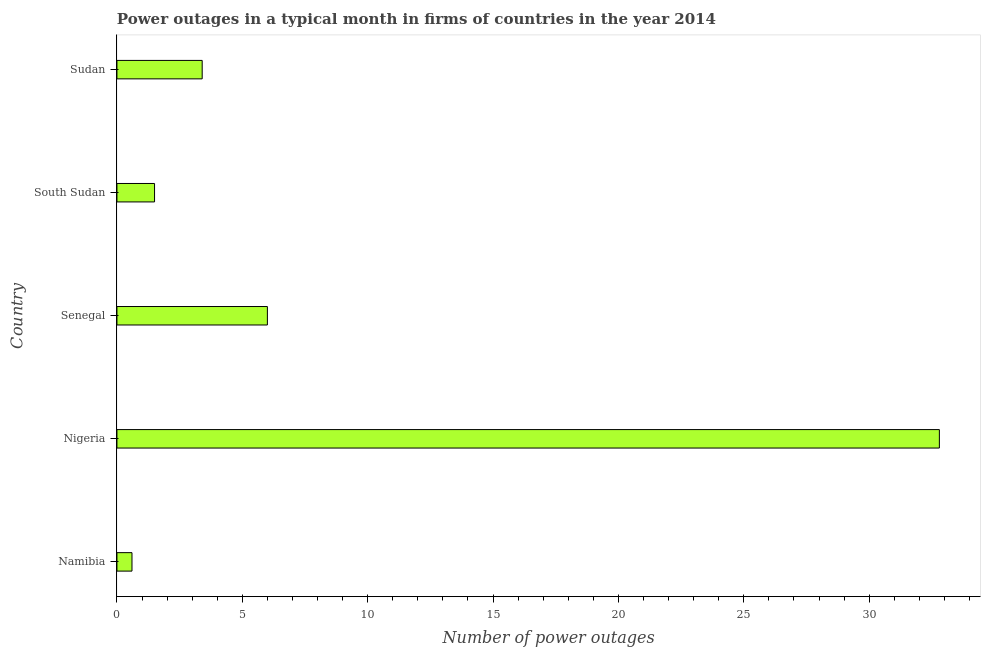What is the title of the graph?
Provide a succinct answer. Power outages in a typical month in firms of countries in the year 2014. What is the label or title of the X-axis?
Offer a terse response. Number of power outages. What is the label or title of the Y-axis?
Provide a short and direct response. Country. What is the number of power outages in South Sudan?
Give a very brief answer. 1.5. Across all countries, what is the maximum number of power outages?
Give a very brief answer. 32.8. In which country was the number of power outages maximum?
Your response must be concise. Nigeria. In which country was the number of power outages minimum?
Ensure brevity in your answer.  Namibia. What is the sum of the number of power outages?
Your answer should be very brief. 44.3. What is the difference between the number of power outages in Namibia and Senegal?
Your answer should be compact. -5.4. What is the average number of power outages per country?
Offer a very short reply. 8.86. In how many countries, is the number of power outages greater than 7 ?
Offer a terse response. 1. What is the ratio of the number of power outages in Namibia to that in Sudan?
Give a very brief answer. 0.18. Is the difference between the number of power outages in Namibia and Senegal greater than the difference between any two countries?
Give a very brief answer. No. What is the difference between the highest and the second highest number of power outages?
Make the answer very short. 26.8. What is the difference between the highest and the lowest number of power outages?
Provide a short and direct response. 32.2. In how many countries, is the number of power outages greater than the average number of power outages taken over all countries?
Give a very brief answer. 1. What is the difference between two consecutive major ticks on the X-axis?
Ensure brevity in your answer.  5. Are the values on the major ticks of X-axis written in scientific E-notation?
Give a very brief answer. No. What is the Number of power outages in Namibia?
Offer a very short reply. 0.6. What is the Number of power outages of Nigeria?
Offer a terse response. 32.8. What is the Number of power outages in Senegal?
Give a very brief answer. 6. What is the Number of power outages of South Sudan?
Ensure brevity in your answer.  1.5. What is the Number of power outages in Sudan?
Give a very brief answer. 3.4. What is the difference between the Number of power outages in Namibia and Nigeria?
Provide a short and direct response. -32.2. What is the difference between the Number of power outages in Nigeria and Senegal?
Provide a succinct answer. 26.8. What is the difference between the Number of power outages in Nigeria and South Sudan?
Your response must be concise. 31.3. What is the difference between the Number of power outages in Nigeria and Sudan?
Your answer should be very brief. 29.4. What is the difference between the Number of power outages in Senegal and South Sudan?
Give a very brief answer. 4.5. What is the difference between the Number of power outages in Senegal and Sudan?
Offer a very short reply. 2.6. What is the difference between the Number of power outages in South Sudan and Sudan?
Provide a short and direct response. -1.9. What is the ratio of the Number of power outages in Namibia to that in Nigeria?
Offer a very short reply. 0.02. What is the ratio of the Number of power outages in Namibia to that in South Sudan?
Provide a succinct answer. 0.4. What is the ratio of the Number of power outages in Namibia to that in Sudan?
Ensure brevity in your answer.  0.18. What is the ratio of the Number of power outages in Nigeria to that in Senegal?
Keep it short and to the point. 5.47. What is the ratio of the Number of power outages in Nigeria to that in South Sudan?
Your answer should be very brief. 21.87. What is the ratio of the Number of power outages in Nigeria to that in Sudan?
Your response must be concise. 9.65. What is the ratio of the Number of power outages in Senegal to that in South Sudan?
Make the answer very short. 4. What is the ratio of the Number of power outages in Senegal to that in Sudan?
Your answer should be compact. 1.76. What is the ratio of the Number of power outages in South Sudan to that in Sudan?
Offer a very short reply. 0.44. 